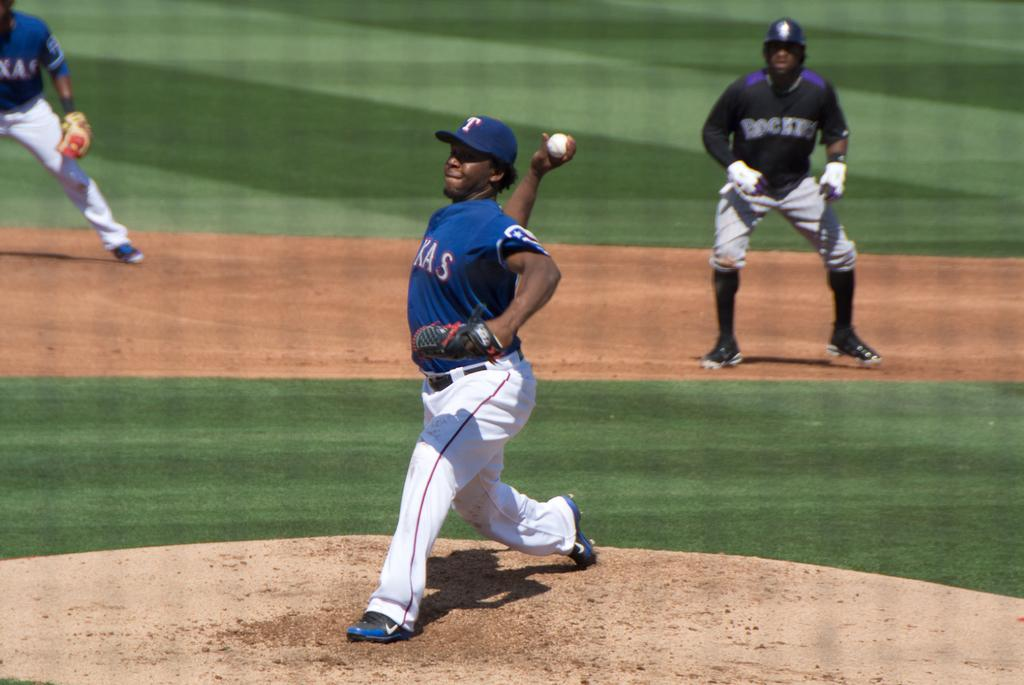<image>
Give a short and clear explanation of the subsequent image. A pitcher winds up a pitch wearing a cap with a letter T on it. 